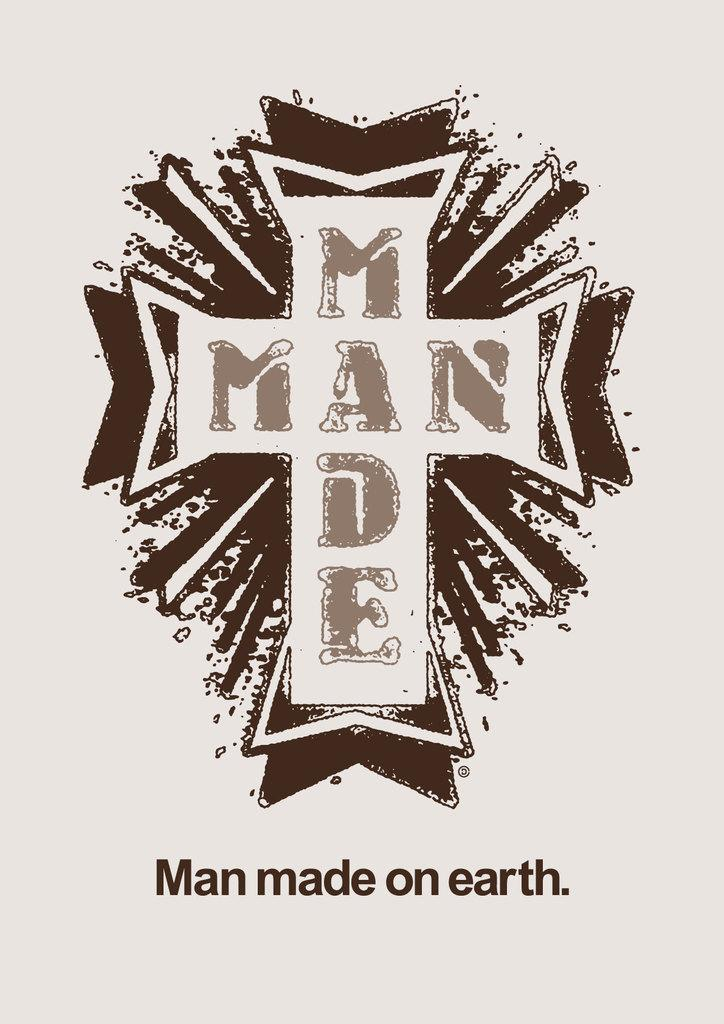<image>
Summarize the visual content of the image. Sign with a cross on it and the words "Man made on earth". 